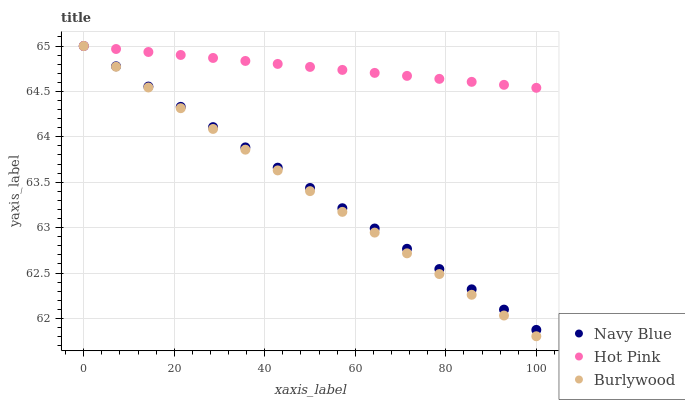Does Burlywood have the minimum area under the curve?
Answer yes or no. Yes. Does Hot Pink have the maximum area under the curve?
Answer yes or no. Yes. Does Navy Blue have the minimum area under the curve?
Answer yes or no. No. Does Navy Blue have the maximum area under the curve?
Answer yes or no. No. Is Hot Pink the smoothest?
Answer yes or no. Yes. Is Burlywood the roughest?
Answer yes or no. Yes. Is Navy Blue the smoothest?
Answer yes or no. No. Is Navy Blue the roughest?
Answer yes or no. No. Does Burlywood have the lowest value?
Answer yes or no. Yes. Does Navy Blue have the lowest value?
Answer yes or no. No. Does Hot Pink have the highest value?
Answer yes or no. Yes. Does Hot Pink intersect Navy Blue?
Answer yes or no. Yes. Is Hot Pink less than Navy Blue?
Answer yes or no. No. Is Hot Pink greater than Navy Blue?
Answer yes or no. No. 